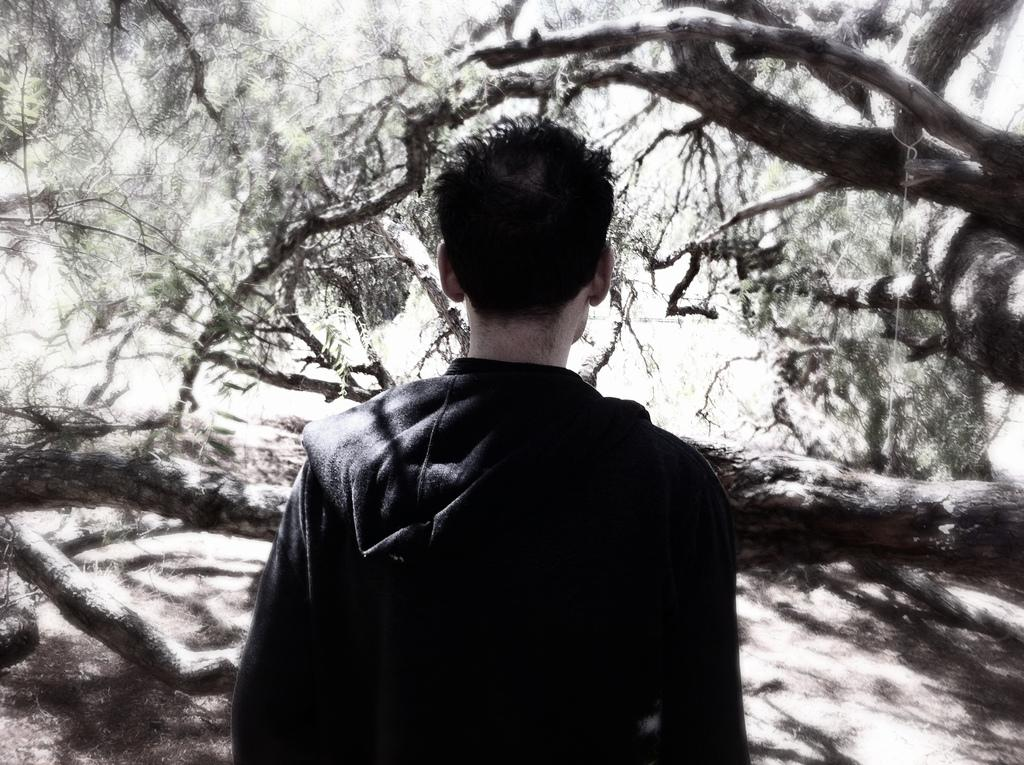Who or what is present in the image? There is a person in the image. What can be seen beneath the person's feet? The ground is visible in the image. What type of natural elements are present in the image? There are trees in the image. What color is the balloon that the person is holding in the image? There is no balloon present in the image. What is the aftermath of the event that took place in the image? There is no event or aftermath mentioned in the provided facts, as the image only shows a person, the ground, and trees. 